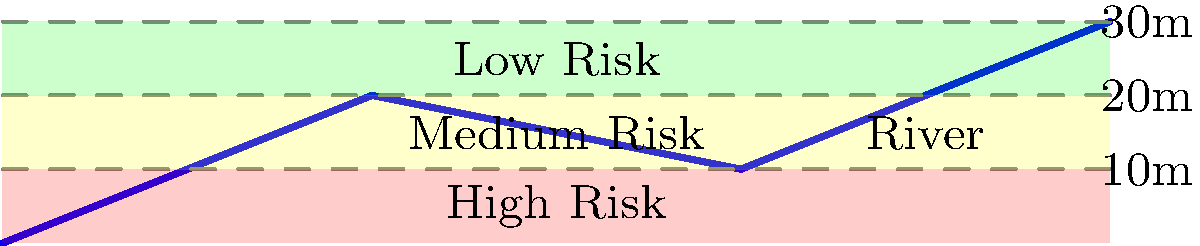As a political reporter covering environmental policies, you're investigating the impact of proposed flood mitigation measures. Using the provided topographical map and river system diagram, which area would you identify as the most critical for immediate flood protection measures, and why might this information be crucial for policymakers? To answer this question, we need to analyze the topographical map and river system diagram:

1. Elevation contours: The map shows three elevation contours at 10m, 20m, and 30m above the river level.

2. Flood risk zones: The areas between these contours are color-coded to indicate different levels of flood risk:
   - Red (0-10m): High risk
   - Yellow (10-20m): Medium risk
   - Green (20-30m): Low risk

3. River system: The blue line represents the river, which flows through the landscape.

4. Critical area: The area closest to the river and below the 10m contour line (colored red) is at the highest risk of flooding. This is because:
   a) It's the lowest-lying area, making it most susceptible to river overflow.
   b) It has the least elevation difference from the river, meaning even a small rise in water levels could cause flooding.

5. Importance for policymakers:
   a) Resource allocation: Knowing the highest risk areas allows for prioritized distribution of flood protection resources.
   b) Urban planning: This information can guide decisions on zoning, construction permits, and infrastructure development.
   c) Emergency response: It helps in creating targeted evacuation plans and emergency response strategies.
   d) Insurance policies: It can inform flood insurance requirements and rates for different areas.
   e) Environmental impact: Understanding flood risks can guide policies on wetland preservation and natural flood mitigation measures.

6. As a political reporter, this information is crucial for:
   a) Evaluating the effectiveness of current and proposed flood mitigation policies.
   b) Investigating potential conflicts between development interests and flood risk management.
   c) Analyzing the equitable distribution of flood protection measures across different communities.
   d) Reporting on the long-term economic and social impacts of flood risks on affected areas.
Answer: The red zone (0-10m elevation) is most critical for immediate flood protection. This information helps policymakers prioritize resources, guide urban planning, prepare emergency responses, set insurance policies, and balance development with environmental concerns. 